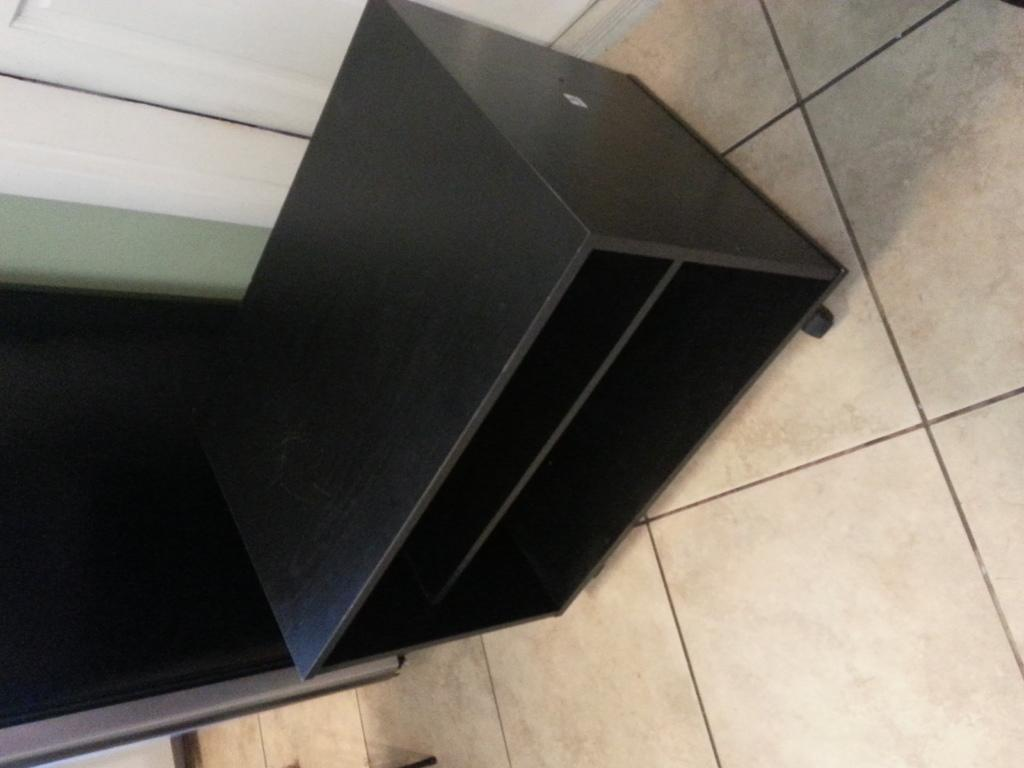What is the main object in the image made of? The main object in the image is made of black-colored wood. What can be seen beneath the object in the image? The floor is visible in the image. What is the color of the door in the image? The door in the image is white-colored. What type of blade is being used to cut the wooden object in the image? There is no blade present in the image, and the wooden object is not being cut. 